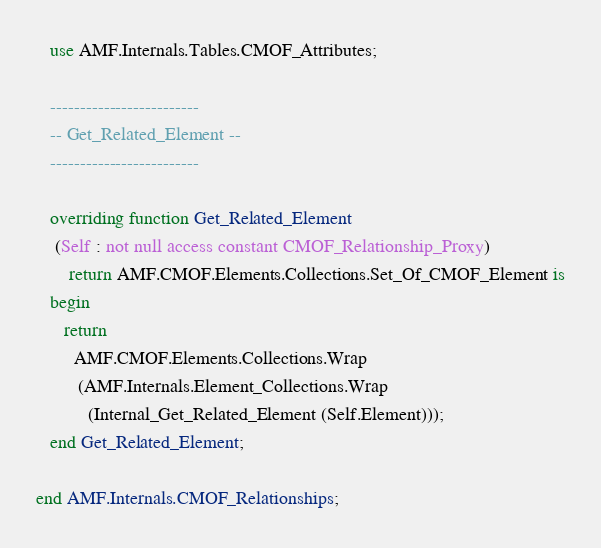Convert code to text. <code><loc_0><loc_0><loc_500><loc_500><_Ada_>   use AMF.Internals.Tables.CMOF_Attributes;

   -------------------------
   -- Get_Related_Element --
   -------------------------

   overriding function Get_Related_Element
    (Self : not null access constant CMOF_Relationship_Proxy)
       return AMF.CMOF.Elements.Collections.Set_Of_CMOF_Element is
   begin
      return
        AMF.CMOF.Elements.Collections.Wrap
         (AMF.Internals.Element_Collections.Wrap
           (Internal_Get_Related_Element (Self.Element)));
   end Get_Related_Element;

end AMF.Internals.CMOF_Relationships;
</code> 